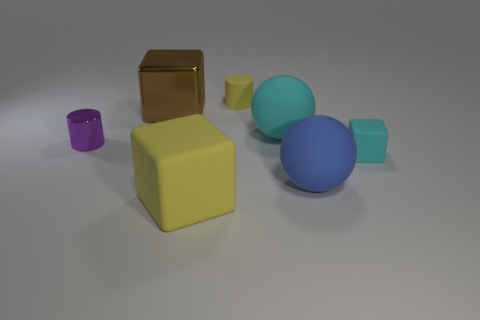The small thing that is on the right side of the brown metallic cube and behind the small cyan matte object has what shape?
Your answer should be compact. Cylinder. How many other objects are there of the same color as the big rubber cube?
Your answer should be compact. 1. How many objects are either small things that are left of the large brown metallic object or large brown metallic cubes?
Offer a very short reply. 2. There is a large matte block; does it have the same color as the tiny cylinder that is to the left of the yellow cylinder?
Provide a short and direct response. No. What size is the cylinder left of the small cylinder behind the small purple object?
Provide a short and direct response. Small. What number of objects are either big green things or cylinders that are in front of the brown metallic cube?
Your response must be concise. 1. Do the shiny thing that is in front of the brown shiny thing and the tiny yellow object have the same shape?
Your answer should be very brief. Yes. There is a big rubber sphere in front of the tiny cylinder that is in front of the tiny yellow rubber object; how many small cubes are in front of it?
Keep it short and to the point. 0. How many things are big green metal cubes or blue balls?
Provide a short and direct response. 1. Is the shape of the small cyan rubber thing the same as the yellow thing that is in front of the cyan matte sphere?
Make the answer very short. Yes. 